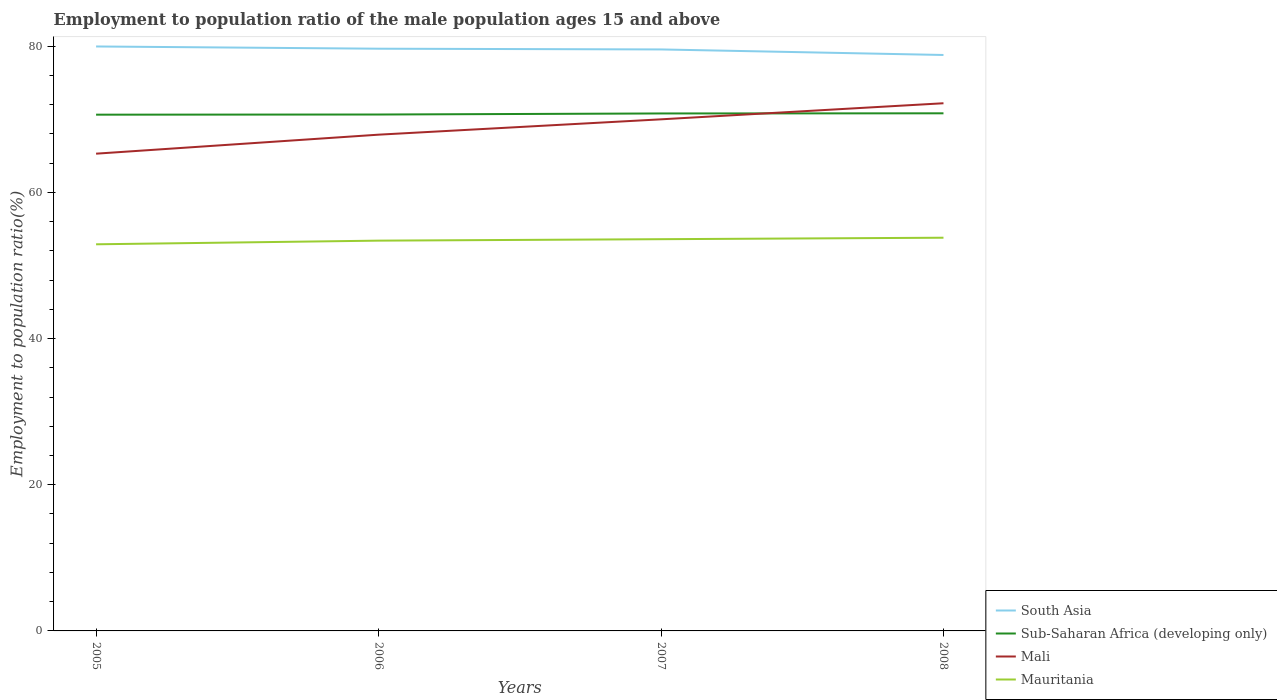Is the number of lines equal to the number of legend labels?
Ensure brevity in your answer.  Yes. Across all years, what is the maximum employment to population ratio in Sub-Saharan Africa (developing only)?
Your answer should be compact. 70.64. What is the total employment to population ratio in Mauritania in the graph?
Keep it short and to the point. -0.5. What is the difference between the highest and the second highest employment to population ratio in Mauritania?
Make the answer very short. 0.9. What is the difference between the highest and the lowest employment to population ratio in South Asia?
Make the answer very short. 3. Are the values on the major ticks of Y-axis written in scientific E-notation?
Ensure brevity in your answer.  No. Does the graph contain any zero values?
Offer a terse response. No. How many legend labels are there?
Provide a succinct answer. 4. How are the legend labels stacked?
Offer a very short reply. Vertical. What is the title of the graph?
Ensure brevity in your answer.  Employment to population ratio of the male population ages 15 and above. Does "Isle of Man" appear as one of the legend labels in the graph?
Your answer should be very brief. No. What is the label or title of the Y-axis?
Keep it short and to the point. Employment to population ratio(%). What is the Employment to population ratio(%) in South Asia in 2005?
Provide a succinct answer. 79.97. What is the Employment to population ratio(%) of Sub-Saharan Africa (developing only) in 2005?
Offer a very short reply. 70.64. What is the Employment to population ratio(%) in Mali in 2005?
Your response must be concise. 65.3. What is the Employment to population ratio(%) in Mauritania in 2005?
Provide a succinct answer. 52.9. What is the Employment to population ratio(%) of South Asia in 2006?
Your answer should be compact. 79.66. What is the Employment to population ratio(%) in Sub-Saharan Africa (developing only) in 2006?
Provide a succinct answer. 70.66. What is the Employment to population ratio(%) in Mali in 2006?
Your answer should be compact. 67.9. What is the Employment to population ratio(%) of Mauritania in 2006?
Keep it short and to the point. 53.4. What is the Employment to population ratio(%) in South Asia in 2007?
Ensure brevity in your answer.  79.56. What is the Employment to population ratio(%) in Sub-Saharan Africa (developing only) in 2007?
Offer a terse response. 70.8. What is the Employment to population ratio(%) of Mauritania in 2007?
Provide a succinct answer. 53.6. What is the Employment to population ratio(%) in South Asia in 2008?
Your answer should be compact. 78.8. What is the Employment to population ratio(%) of Sub-Saharan Africa (developing only) in 2008?
Keep it short and to the point. 70.82. What is the Employment to population ratio(%) of Mali in 2008?
Offer a terse response. 72.2. What is the Employment to population ratio(%) of Mauritania in 2008?
Provide a succinct answer. 53.8. Across all years, what is the maximum Employment to population ratio(%) in South Asia?
Your response must be concise. 79.97. Across all years, what is the maximum Employment to population ratio(%) in Sub-Saharan Africa (developing only)?
Ensure brevity in your answer.  70.82. Across all years, what is the maximum Employment to population ratio(%) in Mali?
Keep it short and to the point. 72.2. Across all years, what is the maximum Employment to population ratio(%) in Mauritania?
Your answer should be compact. 53.8. Across all years, what is the minimum Employment to population ratio(%) in South Asia?
Offer a terse response. 78.8. Across all years, what is the minimum Employment to population ratio(%) in Sub-Saharan Africa (developing only)?
Provide a short and direct response. 70.64. Across all years, what is the minimum Employment to population ratio(%) of Mali?
Offer a terse response. 65.3. Across all years, what is the minimum Employment to population ratio(%) of Mauritania?
Your response must be concise. 52.9. What is the total Employment to population ratio(%) in South Asia in the graph?
Provide a short and direct response. 318. What is the total Employment to population ratio(%) of Sub-Saharan Africa (developing only) in the graph?
Offer a terse response. 282.92. What is the total Employment to population ratio(%) of Mali in the graph?
Your answer should be very brief. 275.4. What is the total Employment to population ratio(%) of Mauritania in the graph?
Provide a short and direct response. 213.7. What is the difference between the Employment to population ratio(%) in South Asia in 2005 and that in 2006?
Provide a short and direct response. 0.3. What is the difference between the Employment to population ratio(%) in Sub-Saharan Africa (developing only) in 2005 and that in 2006?
Your response must be concise. -0.02. What is the difference between the Employment to population ratio(%) in Mali in 2005 and that in 2006?
Your answer should be very brief. -2.6. What is the difference between the Employment to population ratio(%) in Mauritania in 2005 and that in 2006?
Offer a terse response. -0.5. What is the difference between the Employment to population ratio(%) of South Asia in 2005 and that in 2007?
Give a very brief answer. 0.41. What is the difference between the Employment to population ratio(%) in Sub-Saharan Africa (developing only) in 2005 and that in 2007?
Keep it short and to the point. -0.17. What is the difference between the Employment to population ratio(%) of Mauritania in 2005 and that in 2007?
Make the answer very short. -0.7. What is the difference between the Employment to population ratio(%) of South Asia in 2005 and that in 2008?
Your response must be concise. 1.17. What is the difference between the Employment to population ratio(%) of Sub-Saharan Africa (developing only) in 2005 and that in 2008?
Keep it short and to the point. -0.19. What is the difference between the Employment to population ratio(%) in Mauritania in 2005 and that in 2008?
Keep it short and to the point. -0.9. What is the difference between the Employment to population ratio(%) of South Asia in 2006 and that in 2007?
Keep it short and to the point. 0.1. What is the difference between the Employment to population ratio(%) of Sub-Saharan Africa (developing only) in 2006 and that in 2007?
Offer a terse response. -0.15. What is the difference between the Employment to population ratio(%) of Mali in 2006 and that in 2007?
Provide a short and direct response. -2.1. What is the difference between the Employment to population ratio(%) of South Asia in 2006 and that in 2008?
Provide a succinct answer. 0.86. What is the difference between the Employment to population ratio(%) in Sub-Saharan Africa (developing only) in 2006 and that in 2008?
Keep it short and to the point. -0.17. What is the difference between the Employment to population ratio(%) of South Asia in 2007 and that in 2008?
Give a very brief answer. 0.76. What is the difference between the Employment to population ratio(%) in Sub-Saharan Africa (developing only) in 2007 and that in 2008?
Your answer should be very brief. -0.02. What is the difference between the Employment to population ratio(%) in South Asia in 2005 and the Employment to population ratio(%) in Sub-Saharan Africa (developing only) in 2006?
Your response must be concise. 9.31. What is the difference between the Employment to population ratio(%) in South Asia in 2005 and the Employment to population ratio(%) in Mali in 2006?
Offer a very short reply. 12.07. What is the difference between the Employment to population ratio(%) of South Asia in 2005 and the Employment to population ratio(%) of Mauritania in 2006?
Your answer should be compact. 26.57. What is the difference between the Employment to population ratio(%) in Sub-Saharan Africa (developing only) in 2005 and the Employment to population ratio(%) in Mali in 2006?
Your answer should be very brief. 2.74. What is the difference between the Employment to population ratio(%) in Sub-Saharan Africa (developing only) in 2005 and the Employment to population ratio(%) in Mauritania in 2006?
Keep it short and to the point. 17.24. What is the difference between the Employment to population ratio(%) in South Asia in 2005 and the Employment to population ratio(%) in Sub-Saharan Africa (developing only) in 2007?
Offer a terse response. 9.17. What is the difference between the Employment to population ratio(%) in South Asia in 2005 and the Employment to population ratio(%) in Mali in 2007?
Your answer should be very brief. 9.97. What is the difference between the Employment to population ratio(%) of South Asia in 2005 and the Employment to population ratio(%) of Mauritania in 2007?
Give a very brief answer. 26.37. What is the difference between the Employment to population ratio(%) in Sub-Saharan Africa (developing only) in 2005 and the Employment to population ratio(%) in Mali in 2007?
Offer a terse response. 0.64. What is the difference between the Employment to population ratio(%) in Sub-Saharan Africa (developing only) in 2005 and the Employment to population ratio(%) in Mauritania in 2007?
Ensure brevity in your answer.  17.04. What is the difference between the Employment to population ratio(%) in Mali in 2005 and the Employment to population ratio(%) in Mauritania in 2007?
Offer a terse response. 11.7. What is the difference between the Employment to population ratio(%) in South Asia in 2005 and the Employment to population ratio(%) in Sub-Saharan Africa (developing only) in 2008?
Your response must be concise. 9.15. What is the difference between the Employment to population ratio(%) in South Asia in 2005 and the Employment to population ratio(%) in Mali in 2008?
Give a very brief answer. 7.77. What is the difference between the Employment to population ratio(%) of South Asia in 2005 and the Employment to population ratio(%) of Mauritania in 2008?
Keep it short and to the point. 26.17. What is the difference between the Employment to population ratio(%) in Sub-Saharan Africa (developing only) in 2005 and the Employment to population ratio(%) in Mali in 2008?
Provide a short and direct response. -1.56. What is the difference between the Employment to population ratio(%) of Sub-Saharan Africa (developing only) in 2005 and the Employment to population ratio(%) of Mauritania in 2008?
Your answer should be compact. 16.84. What is the difference between the Employment to population ratio(%) of South Asia in 2006 and the Employment to population ratio(%) of Sub-Saharan Africa (developing only) in 2007?
Give a very brief answer. 8.86. What is the difference between the Employment to population ratio(%) in South Asia in 2006 and the Employment to population ratio(%) in Mali in 2007?
Give a very brief answer. 9.66. What is the difference between the Employment to population ratio(%) of South Asia in 2006 and the Employment to population ratio(%) of Mauritania in 2007?
Provide a succinct answer. 26.06. What is the difference between the Employment to population ratio(%) in Sub-Saharan Africa (developing only) in 2006 and the Employment to population ratio(%) in Mali in 2007?
Your answer should be compact. 0.66. What is the difference between the Employment to population ratio(%) of Sub-Saharan Africa (developing only) in 2006 and the Employment to population ratio(%) of Mauritania in 2007?
Give a very brief answer. 17.06. What is the difference between the Employment to population ratio(%) of Mali in 2006 and the Employment to population ratio(%) of Mauritania in 2007?
Offer a very short reply. 14.3. What is the difference between the Employment to population ratio(%) of South Asia in 2006 and the Employment to population ratio(%) of Sub-Saharan Africa (developing only) in 2008?
Offer a very short reply. 8.84. What is the difference between the Employment to population ratio(%) of South Asia in 2006 and the Employment to population ratio(%) of Mali in 2008?
Your answer should be very brief. 7.46. What is the difference between the Employment to population ratio(%) in South Asia in 2006 and the Employment to population ratio(%) in Mauritania in 2008?
Keep it short and to the point. 25.86. What is the difference between the Employment to population ratio(%) in Sub-Saharan Africa (developing only) in 2006 and the Employment to population ratio(%) in Mali in 2008?
Provide a short and direct response. -1.54. What is the difference between the Employment to population ratio(%) in Sub-Saharan Africa (developing only) in 2006 and the Employment to population ratio(%) in Mauritania in 2008?
Provide a succinct answer. 16.86. What is the difference between the Employment to population ratio(%) in Mali in 2006 and the Employment to population ratio(%) in Mauritania in 2008?
Offer a very short reply. 14.1. What is the difference between the Employment to population ratio(%) of South Asia in 2007 and the Employment to population ratio(%) of Sub-Saharan Africa (developing only) in 2008?
Ensure brevity in your answer.  8.74. What is the difference between the Employment to population ratio(%) in South Asia in 2007 and the Employment to population ratio(%) in Mali in 2008?
Your response must be concise. 7.36. What is the difference between the Employment to population ratio(%) in South Asia in 2007 and the Employment to population ratio(%) in Mauritania in 2008?
Ensure brevity in your answer.  25.76. What is the difference between the Employment to population ratio(%) in Sub-Saharan Africa (developing only) in 2007 and the Employment to population ratio(%) in Mali in 2008?
Make the answer very short. -1.4. What is the difference between the Employment to population ratio(%) in Sub-Saharan Africa (developing only) in 2007 and the Employment to population ratio(%) in Mauritania in 2008?
Provide a short and direct response. 17. What is the average Employment to population ratio(%) in South Asia per year?
Ensure brevity in your answer.  79.5. What is the average Employment to population ratio(%) of Sub-Saharan Africa (developing only) per year?
Offer a terse response. 70.73. What is the average Employment to population ratio(%) of Mali per year?
Make the answer very short. 68.85. What is the average Employment to population ratio(%) of Mauritania per year?
Provide a short and direct response. 53.42. In the year 2005, what is the difference between the Employment to population ratio(%) of South Asia and Employment to population ratio(%) of Sub-Saharan Africa (developing only)?
Your answer should be very brief. 9.33. In the year 2005, what is the difference between the Employment to population ratio(%) of South Asia and Employment to population ratio(%) of Mali?
Keep it short and to the point. 14.67. In the year 2005, what is the difference between the Employment to population ratio(%) in South Asia and Employment to population ratio(%) in Mauritania?
Give a very brief answer. 27.07. In the year 2005, what is the difference between the Employment to population ratio(%) in Sub-Saharan Africa (developing only) and Employment to population ratio(%) in Mali?
Your answer should be very brief. 5.34. In the year 2005, what is the difference between the Employment to population ratio(%) of Sub-Saharan Africa (developing only) and Employment to population ratio(%) of Mauritania?
Make the answer very short. 17.74. In the year 2005, what is the difference between the Employment to population ratio(%) in Mali and Employment to population ratio(%) in Mauritania?
Provide a succinct answer. 12.4. In the year 2006, what is the difference between the Employment to population ratio(%) in South Asia and Employment to population ratio(%) in Sub-Saharan Africa (developing only)?
Your answer should be very brief. 9.01. In the year 2006, what is the difference between the Employment to population ratio(%) of South Asia and Employment to population ratio(%) of Mali?
Offer a very short reply. 11.76. In the year 2006, what is the difference between the Employment to population ratio(%) in South Asia and Employment to population ratio(%) in Mauritania?
Provide a short and direct response. 26.26. In the year 2006, what is the difference between the Employment to population ratio(%) of Sub-Saharan Africa (developing only) and Employment to population ratio(%) of Mali?
Your response must be concise. 2.76. In the year 2006, what is the difference between the Employment to population ratio(%) in Sub-Saharan Africa (developing only) and Employment to population ratio(%) in Mauritania?
Your answer should be very brief. 17.26. In the year 2007, what is the difference between the Employment to population ratio(%) in South Asia and Employment to population ratio(%) in Sub-Saharan Africa (developing only)?
Provide a short and direct response. 8.76. In the year 2007, what is the difference between the Employment to population ratio(%) of South Asia and Employment to population ratio(%) of Mali?
Provide a succinct answer. 9.56. In the year 2007, what is the difference between the Employment to population ratio(%) of South Asia and Employment to population ratio(%) of Mauritania?
Offer a very short reply. 25.96. In the year 2007, what is the difference between the Employment to population ratio(%) in Sub-Saharan Africa (developing only) and Employment to population ratio(%) in Mali?
Keep it short and to the point. 0.8. In the year 2007, what is the difference between the Employment to population ratio(%) in Sub-Saharan Africa (developing only) and Employment to population ratio(%) in Mauritania?
Your response must be concise. 17.2. In the year 2007, what is the difference between the Employment to population ratio(%) of Mali and Employment to population ratio(%) of Mauritania?
Offer a very short reply. 16.4. In the year 2008, what is the difference between the Employment to population ratio(%) of South Asia and Employment to population ratio(%) of Sub-Saharan Africa (developing only)?
Ensure brevity in your answer.  7.98. In the year 2008, what is the difference between the Employment to population ratio(%) of South Asia and Employment to population ratio(%) of Mali?
Keep it short and to the point. 6.6. In the year 2008, what is the difference between the Employment to population ratio(%) in South Asia and Employment to population ratio(%) in Mauritania?
Your response must be concise. 25. In the year 2008, what is the difference between the Employment to population ratio(%) in Sub-Saharan Africa (developing only) and Employment to population ratio(%) in Mali?
Provide a succinct answer. -1.38. In the year 2008, what is the difference between the Employment to population ratio(%) of Sub-Saharan Africa (developing only) and Employment to population ratio(%) of Mauritania?
Your response must be concise. 17.02. What is the ratio of the Employment to population ratio(%) in Mali in 2005 to that in 2006?
Give a very brief answer. 0.96. What is the ratio of the Employment to population ratio(%) in Mauritania in 2005 to that in 2006?
Your response must be concise. 0.99. What is the ratio of the Employment to population ratio(%) of Mali in 2005 to that in 2007?
Provide a short and direct response. 0.93. What is the ratio of the Employment to population ratio(%) of Mauritania in 2005 to that in 2007?
Keep it short and to the point. 0.99. What is the ratio of the Employment to population ratio(%) in South Asia in 2005 to that in 2008?
Your answer should be compact. 1.01. What is the ratio of the Employment to population ratio(%) in Sub-Saharan Africa (developing only) in 2005 to that in 2008?
Offer a terse response. 1. What is the ratio of the Employment to population ratio(%) of Mali in 2005 to that in 2008?
Make the answer very short. 0.9. What is the ratio of the Employment to population ratio(%) in Mauritania in 2005 to that in 2008?
Provide a succinct answer. 0.98. What is the ratio of the Employment to population ratio(%) of Sub-Saharan Africa (developing only) in 2006 to that in 2007?
Your answer should be very brief. 1. What is the ratio of the Employment to population ratio(%) of Mali in 2006 to that in 2007?
Offer a terse response. 0.97. What is the ratio of the Employment to population ratio(%) of Mauritania in 2006 to that in 2007?
Give a very brief answer. 1. What is the ratio of the Employment to population ratio(%) of South Asia in 2006 to that in 2008?
Your answer should be very brief. 1.01. What is the ratio of the Employment to population ratio(%) of Mali in 2006 to that in 2008?
Keep it short and to the point. 0.94. What is the ratio of the Employment to population ratio(%) in Mauritania in 2006 to that in 2008?
Offer a very short reply. 0.99. What is the ratio of the Employment to population ratio(%) of South Asia in 2007 to that in 2008?
Ensure brevity in your answer.  1.01. What is the ratio of the Employment to population ratio(%) of Mali in 2007 to that in 2008?
Ensure brevity in your answer.  0.97. What is the difference between the highest and the second highest Employment to population ratio(%) in South Asia?
Offer a terse response. 0.3. What is the difference between the highest and the second highest Employment to population ratio(%) in Sub-Saharan Africa (developing only)?
Your answer should be compact. 0.02. What is the difference between the highest and the lowest Employment to population ratio(%) in South Asia?
Offer a very short reply. 1.17. What is the difference between the highest and the lowest Employment to population ratio(%) in Sub-Saharan Africa (developing only)?
Your response must be concise. 0.19. What is the difference between the highest and the lowest Employment to population ratio(%) of Mali?
Keep it short and to the point. 6.9. What is the difference between the highest and the lowest Employment to population ratio(%) of Mauritania?
Give a very brief answer. 0.9. 